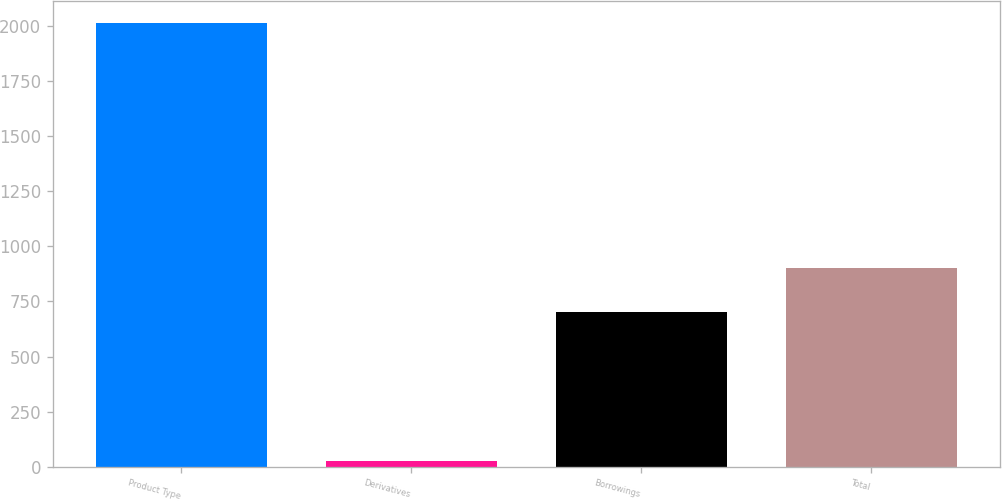Convert chart to OTSL. <chart><loc_0><loc_0><loc_500><loc_500><bar_chart><fcel>Product Type<fcel>Derivatives<fcel>Borrowings<fcel>Total<nl><fcel>2012<fcel>29<fcel>703<fcel>901.3<nl></chart> 